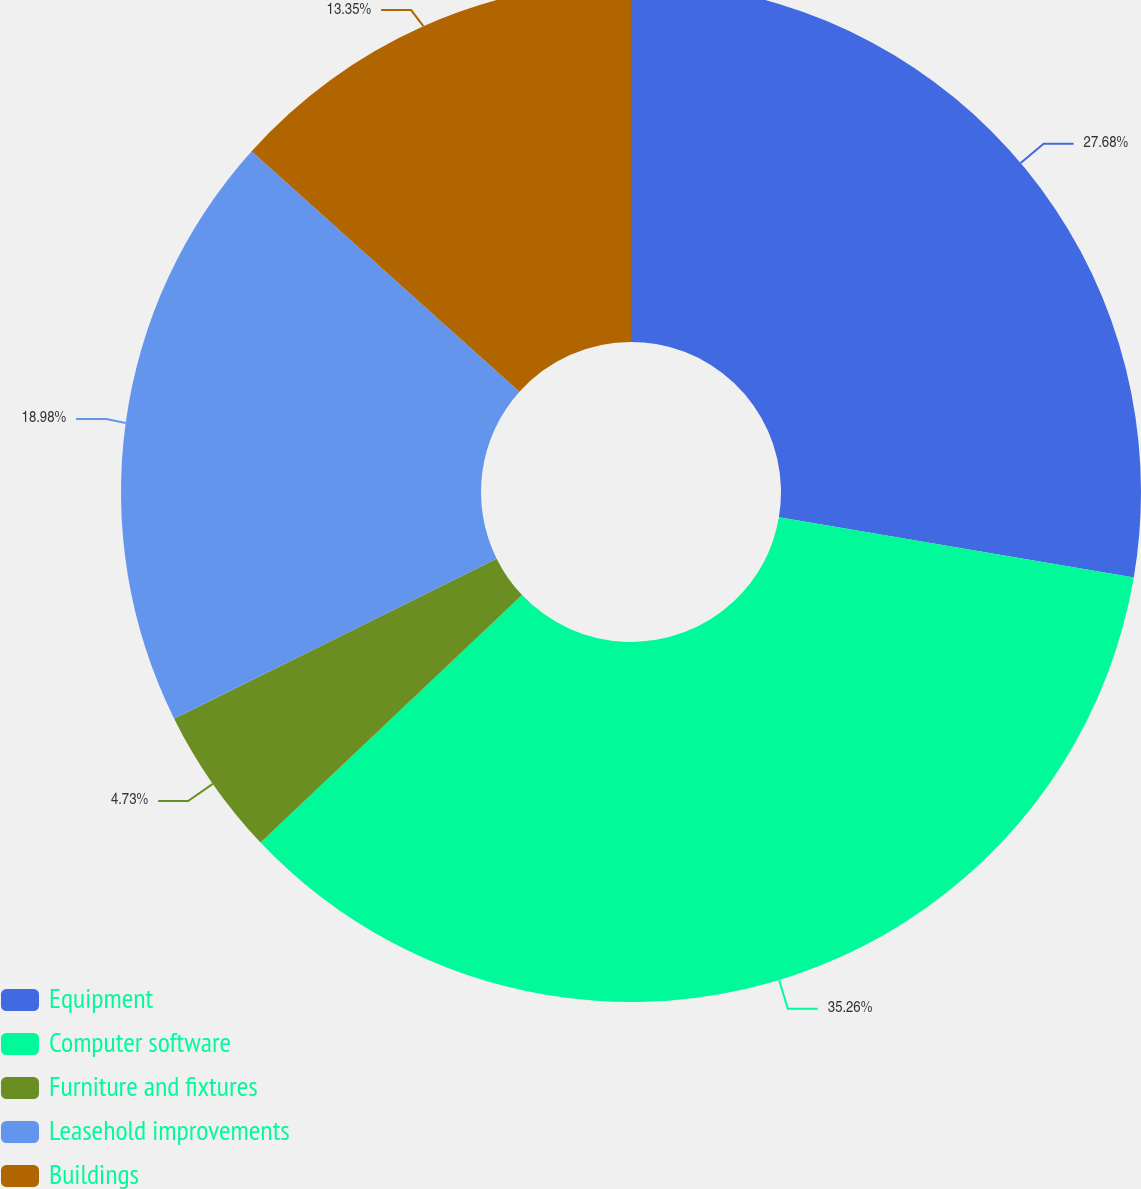<chart> <loc_0><loc_0><loc_500><loc_500><pie_chart><fcel>Equipment<fcel>Computer software<fcel>Furniture and fixtures<fcel>Leasehold improvements<fcel>Buildings<nl><fcel>27.68%<fcel>35.26%<fcel>4.73%<fcel>18.98%<fcel>13.35%<nl></chart> 